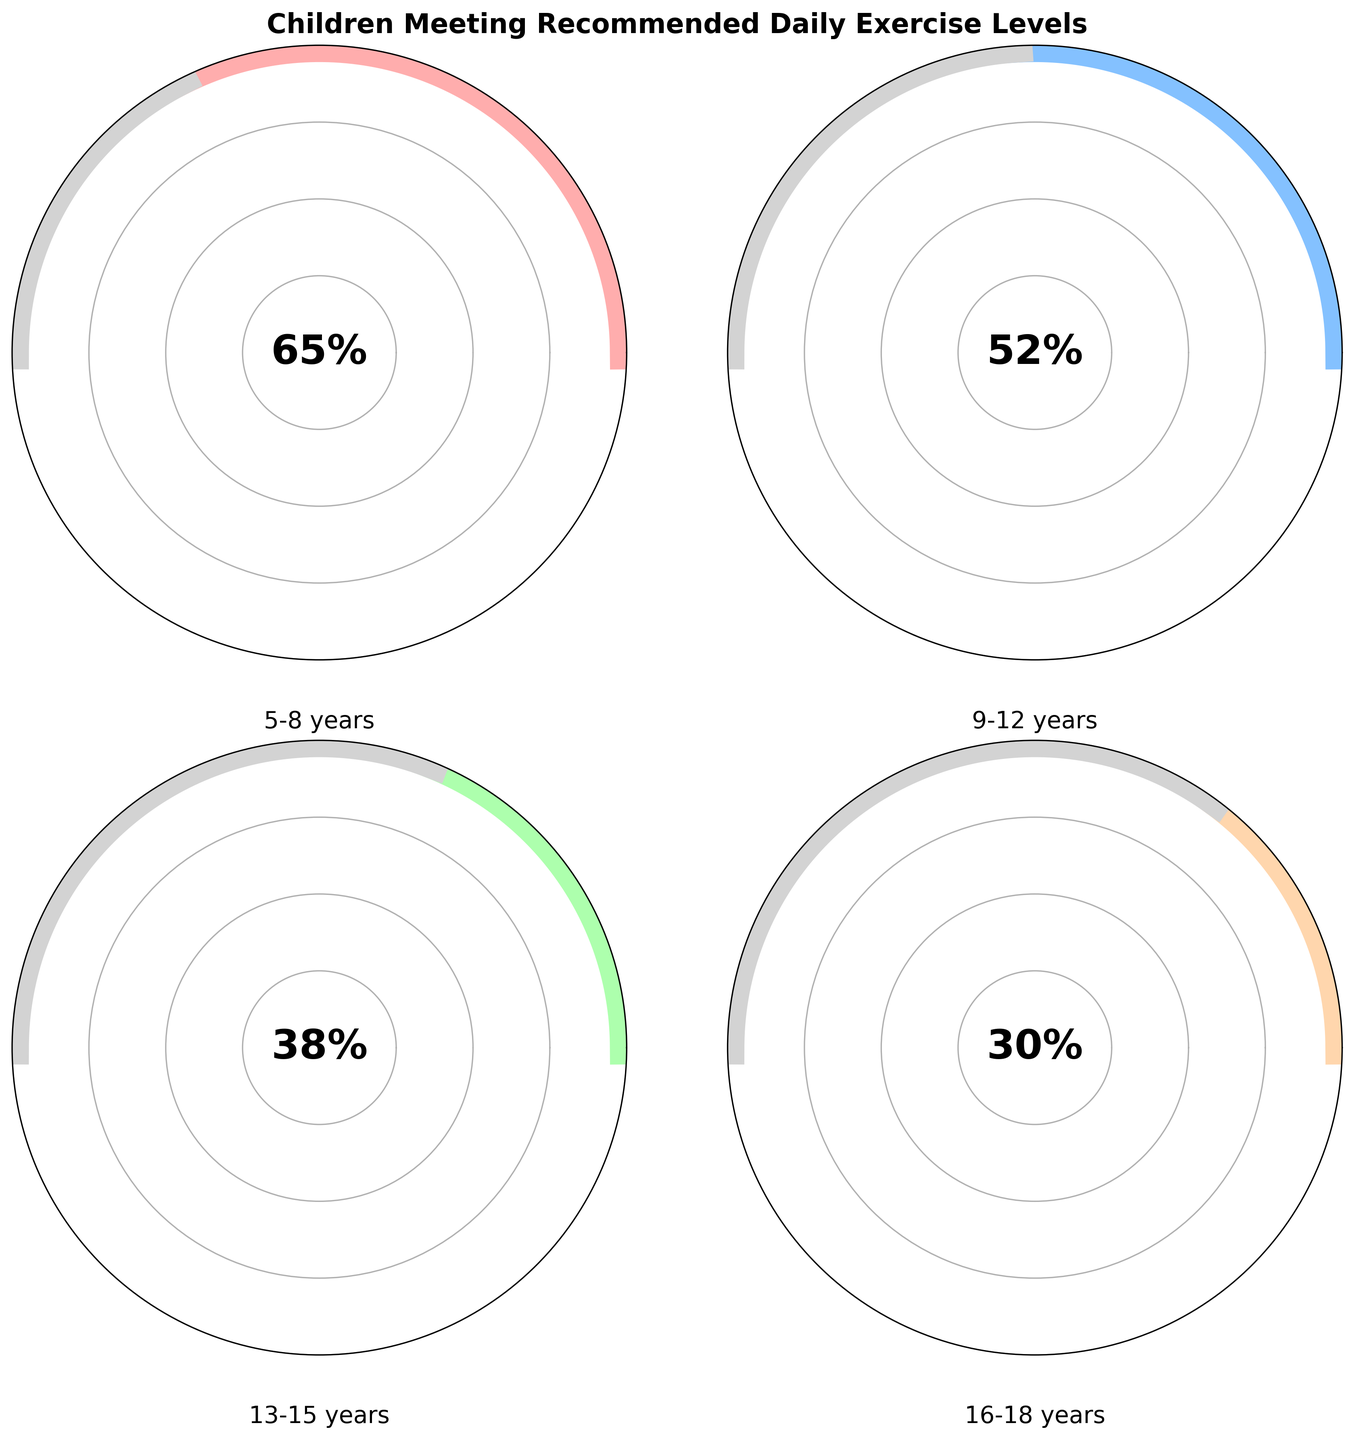How many age groups are shown in the figure? There are four separate gauge charts in the figure, each representing a different age group.
Answer: 4 What is the title of the figure? The title is located at the top of the figure. It reads "Children Meeting Recommended Daily Exercise Levels".
Answer: Children Meeting Recommended Daily Exercise Levels What percentage of children aged 5-8 years meet the recommended daily exercise levels? The gauge chart for the 5-8 years age group shows a percentage of 65%.
Answer: 65% Which age group has the lowest percentage of children meeting the recommended daily exercise levels? By examining each gauge, the age group with the smallest arc in color represents the lowest percentage. The 16-18 years age group has the smallest arc, showing 30%.
Answer: 16-18 years What is the difference in percentages between the age groups 5-8 years and 13-15 years? The percentage for 5-8 years is 65%, and for 13-15 years it is 38%. The difference is calculated as 65% - 38%.
Answer: 27% Which age group shows a percentage value closest to 40%? The gauge charts for each age group indicate the following percentages: 65%, 52%, 38%, and 30%. The value closest to 40% is 38%, which corresponds to the 13-15 years age group.
Answer: 13-15 years Rank the age groups from highest to lowest percentage of children meeting the recommended daily exercise levels. The figure shows the percentages for each age group as 65%, 52%, 38%, and 30%. When ranked from highest to lowest, the order is 5-8 years, 9-12 years, 13-15 years, and 16-18 years.
Answer: 5-8 years, 9-12 years, 13-15 years, 16-18 years If we combine the 9-12 years and 13-15 years age groups, what is their average percentage? The percentages for the 9-12 years and 13-15 years are 52% and 38%, respectively. The average is calculated as (52% + 38%) / 2.
Answer: 45% Between which two consecutive age groups is the drop in percentages the largest? The percentage drops are between 5-8 years to 9-12 years (65% - 52% = 13%), 9-12 years to 13-15 years (52% - 38% = 14%), and 13-15 years to 16-18 years (38% - 30% = 8%). The largest drop is between the 9-12 years and 13-15 years age groups.
Answer: 9-12 years and 13-15 years 